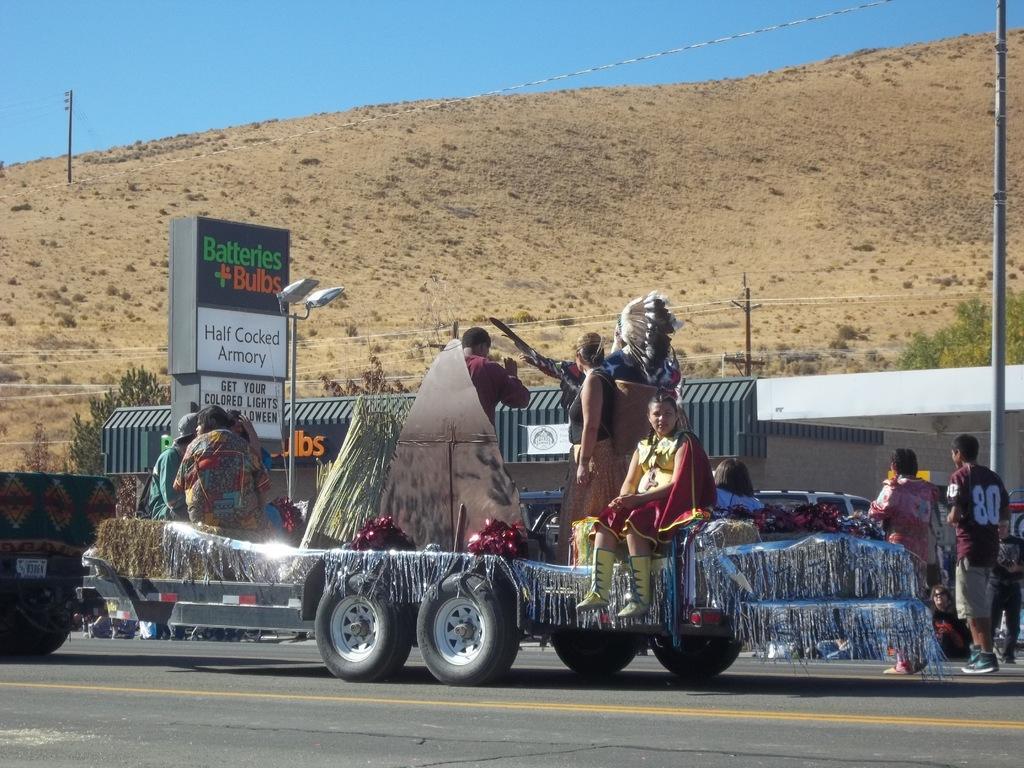In one or two sentences, can you explain what this image depicts? In this picture we can see few cars and a truck, and we can find few people are seated on the truck, in the background we can see few hoardings, shed, trees and poles. 